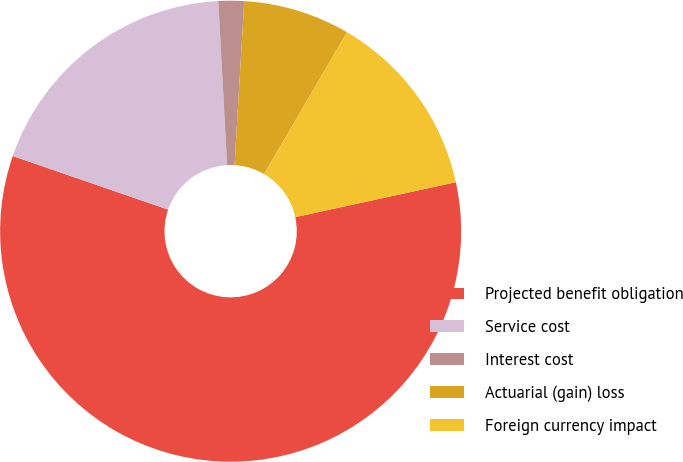Convert chart to OTSL. <chart><loc_0><loc_0><loc_500><loc_500><pie_chart><fcel>Projected benefit obligation<fcel>Service cost<fcel>Interest cost<fcel>Actuarial (gain) loss<fcel>Foreign currency impact<nl><fcel>58.69%<fcel>18.86%<fcel>1.79%<fcel>7.48%<fcel>13.17%<nl></chart> 